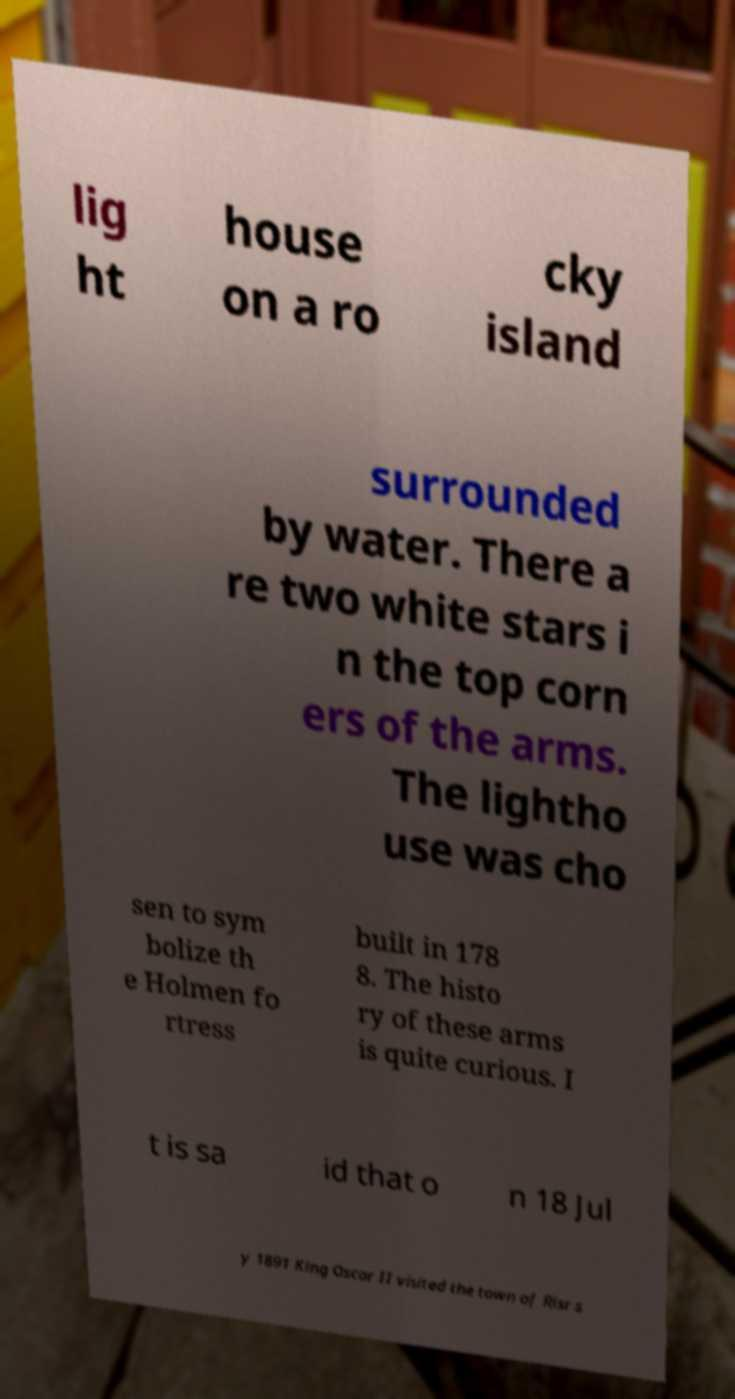Can you accurately transcribe the text from the provided image for me? lig ht house on a ro cky island surrounded by water. There a re two white stars i n the top corn ers of the arms. The lightho use was cho sen to sym bolize th e Holmen fo rtress built in 178 8. The histo ry of these arms is quite curious. I t is sa id that o n 18 Jul y 1891 King Oscar II visited the town of Risr s 